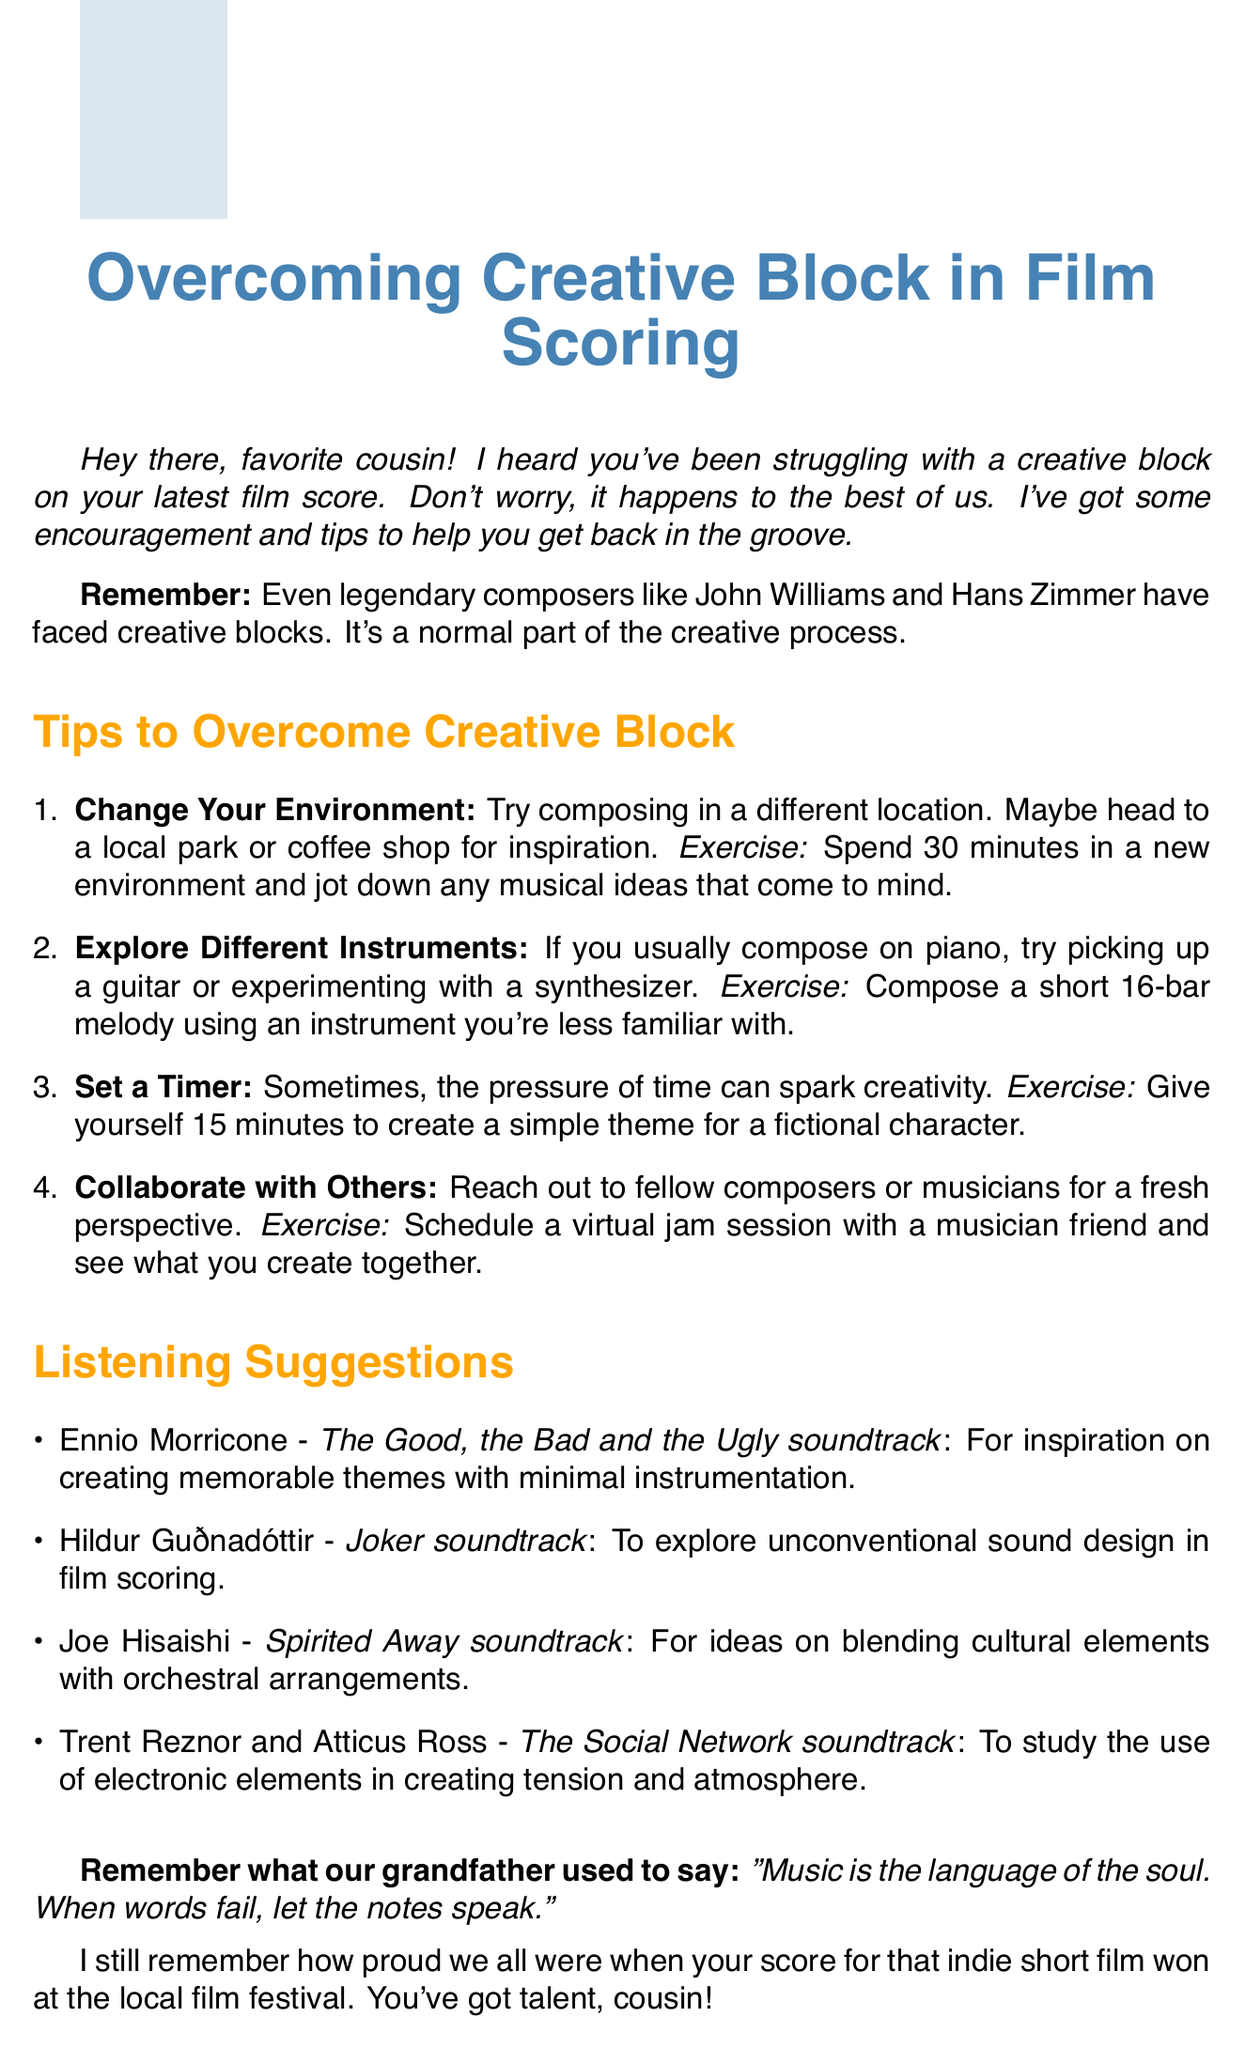What is the opening statement in the memo? The opening statement introduces the memo and expresses empathy towards the reader's struggle with creative block.
Answer: Hey there, favorite cousin! I heard you've been struggling with a creative block on your latest film score. Don't worry, it happens to the best of us What is the first tip for overcoming creative block? The first tip offers a way to change perspective and find inspiration by altering the environment.
Answer: Change Your Environment What is one exercise suggested for exploring different instruments? The document suggests a specific task related to an unfamiliar instrument to encourage creativity.
Answer: Compose a short 16-bar melody using an instrument you're less familiar with Who composed the soundtrack for "The Social Network"? The document mentions specific composers and their works, highlighting an example of tension and atmosphere in film scoring.
Answer: Trent Reznor and Atticus Ross What does the personal anecdote in the encouragement section highlight? The personal anecdote adds a supportive element by recalling a past success of the reader.
Answer: Your score for that indie short film won at the local film festival What is the last encouragement provided in the conclusion? The conclusion of the memo reinforces a positive mindset and suggests celebrating progress.
Answer: Keep pushing through, and don't forget to celebrate small victories along the way 